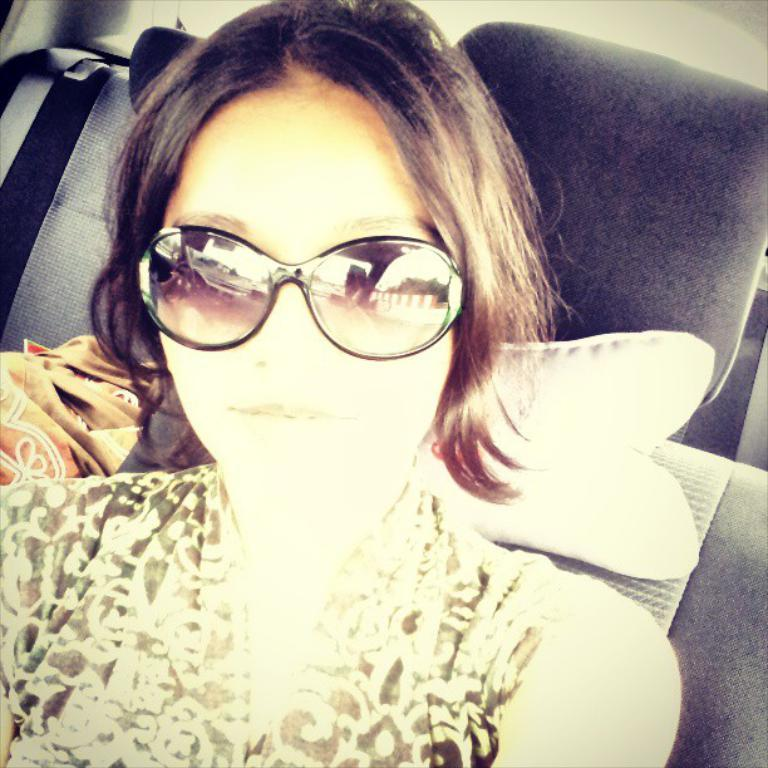What is the main subject of the image? There is a beautiful girl in the image. What is the girl doing in the image? The girl is sitting in a vehicle. What is the girl wearing in the image? The girl is wearing a dress and spectacles. What type of drink does the girl have in her hand in the image? There is no drink visible in the girl's hand in the image. 